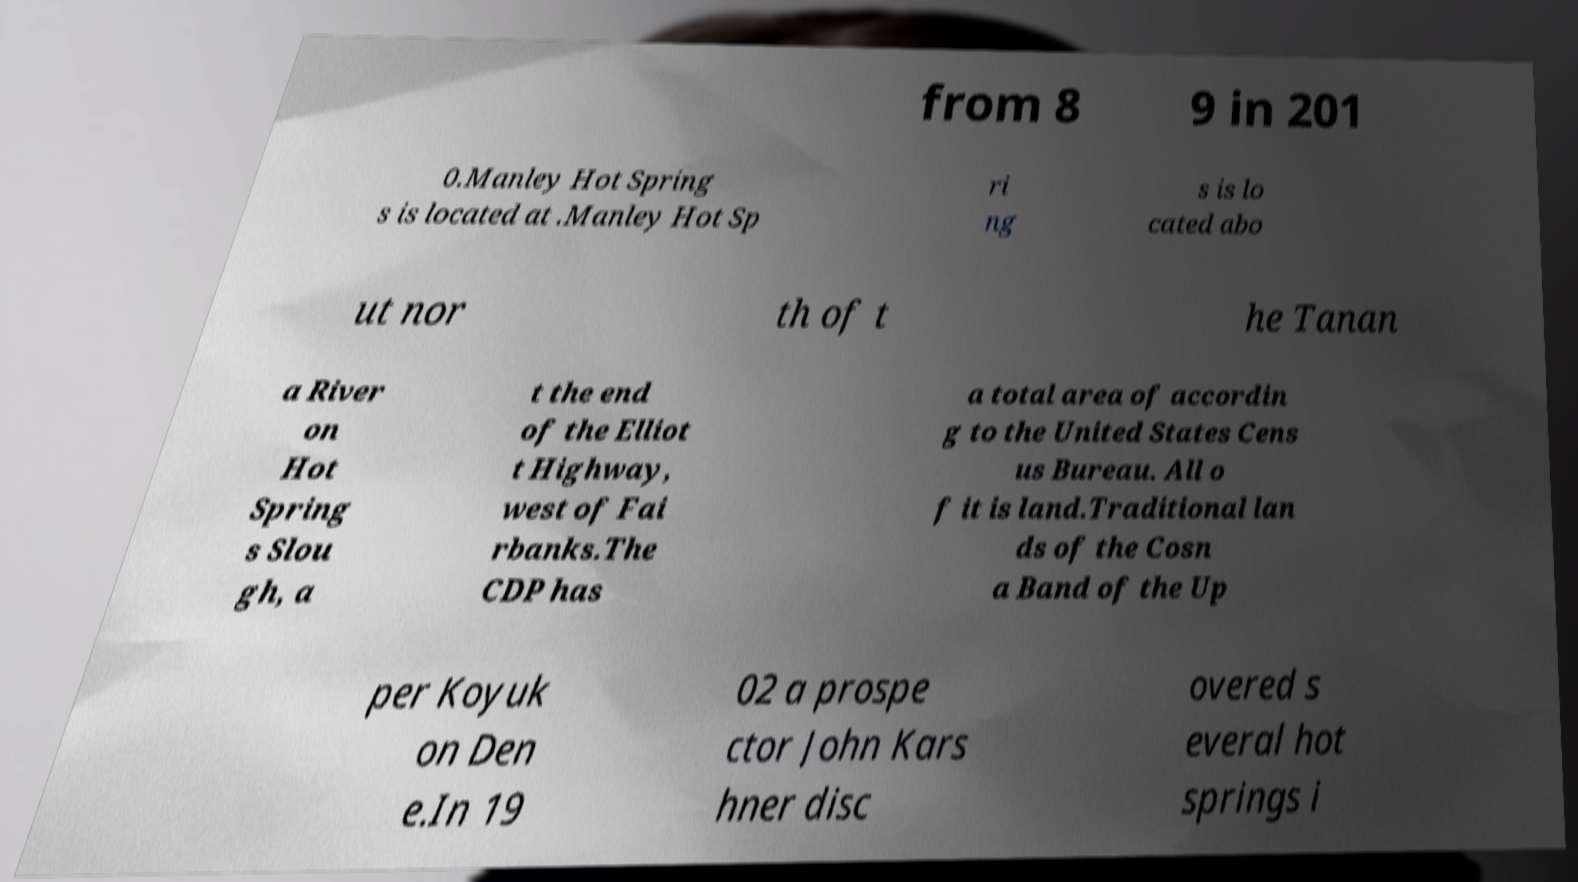What messages or text are displayed in this image? I need them in a readable, typed format. from 8 9 in 201 0.Manley Hot Spring s is located at .Manley Hot Sp ri ng s is lo cated abo ut nor th of t he Tanan a River on Hot Spring s Slou gh, a t the end of the Elliot t Highway, west of Fai rbanks.The CDP has a total area of accordin g to the United States Cens us Bureau. All o f it is land.Traditional lan ds of the Cosn a Band of the Up per Koyuk on Den e.In 19 02 a prospe ctor John Kars hner disc overed s everal hot springs i 